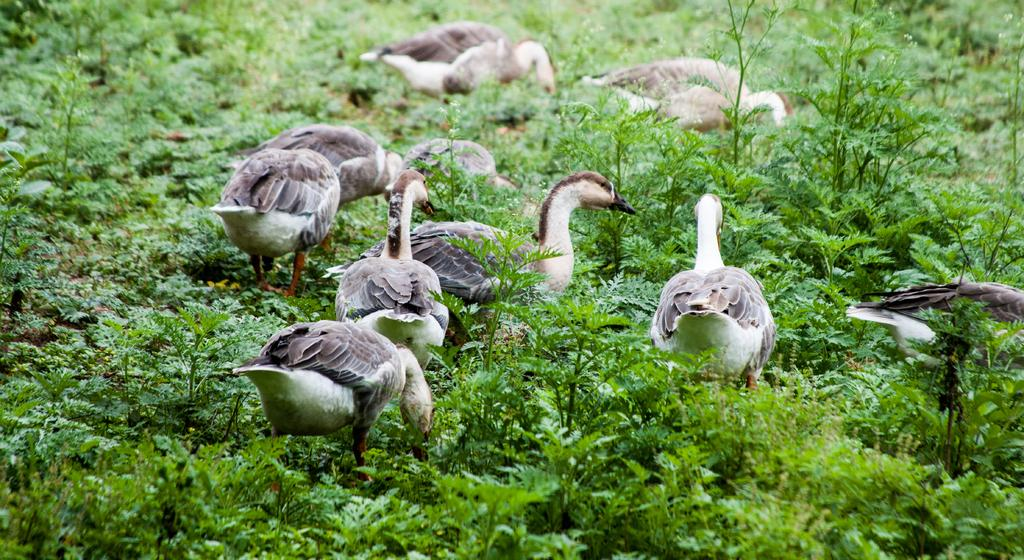What type of animals are in the image? There are no animals present in the image; it features a group of people sitting around a table. What might be the purpose of the gathering in the image? The purpose of the gathering cannot be definitively determined from the image, but they are having a meal together. What is the color of the table in the image? The color of the table is not mentioned in the provided facts. How many minutes does it take for the system to process the data in the image? There is no system or data processing activity depicted in the image, so it is not possible to determine how many minutes it would take. 